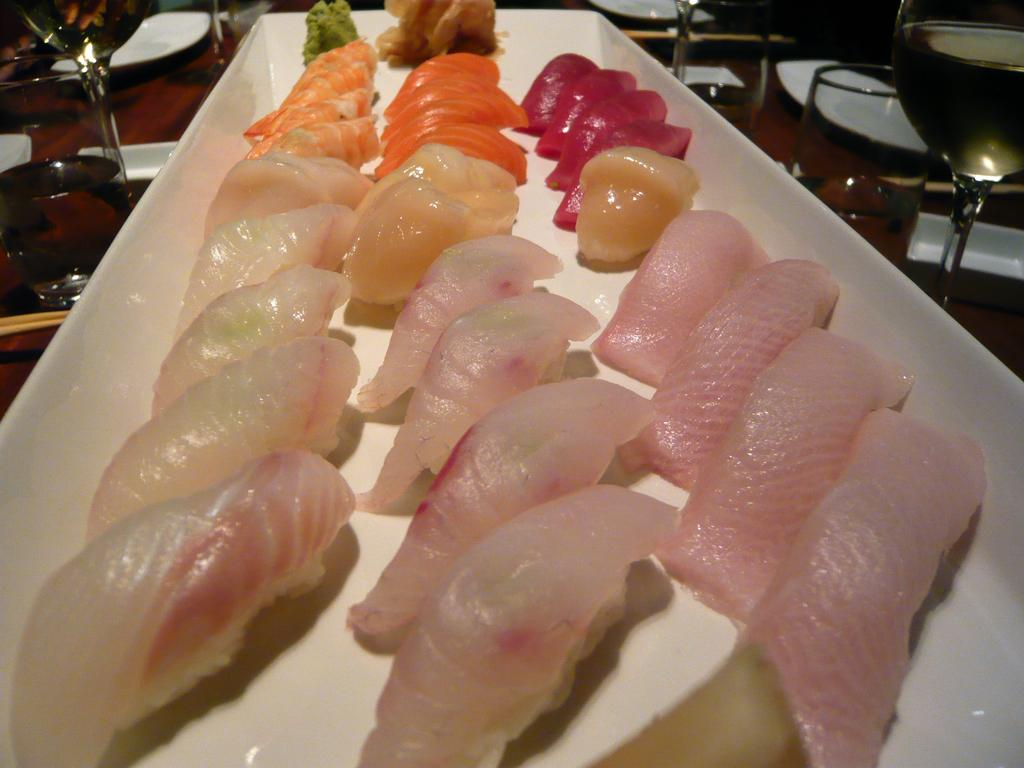What type of food is on the platter in the image? There is seafood on a platter in the image. What might be used for drinking in the image? Glasses are present in the image. What is the main object holding the seafood in the image? There is a platter in the image. What utensils are visible in the image? Chopsticks are visible in the image. What surface is the platter and glasses placed on in the image? There is a table in the image. What language is being spoken by the seafood in the image? The seafood in the image does not speak a language, as it is food and not a living being. 